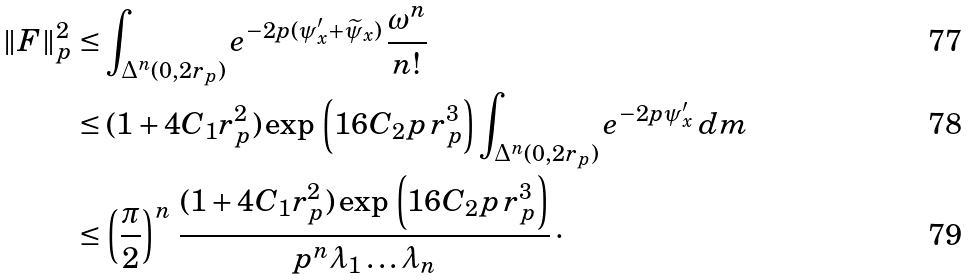<formula> <loc_0><loc_0><loc_500><loc_500>\| F \| ^ { 2 } _ { p } & \leq \int _ { \Delta ^ { n } ( 0 , 2 r _ { p } ) } e ^ { - 2 p ( \psi _ { x } ^ { \prime } + \widetilde { \psi } _ { x } ) } \, \frac { \omega ^ { n } } { n ! } \\ & \leq ( 1 + 4 C _ { 1 } r ^ { 2 } _ { p } ) \exp \, \left ( 1 6 C _ { 2 } p \, r _ { p } ^ { 3 } \right ) \int _ { \Delta ^ { n } ( 0 , 2 r _ { p } ) } e ^ { - 2 p \psi ^ { \prime } _ { x } } \, d m \\ & \leq \left ( \frac { \pi } { 2 } \right ) ^ { n } \, \frac { ( 1 + 4 C _ { 1 } r _ { p } ^ { 2 } ) \exp \, \left ( 1 6 C _ { 2 } p \, r _ { p } ^ { 3 } \right ) } { p ^ { n } \lambda _ { 1 } \dots \lambda _ { n } } \, \cdot</formula> 